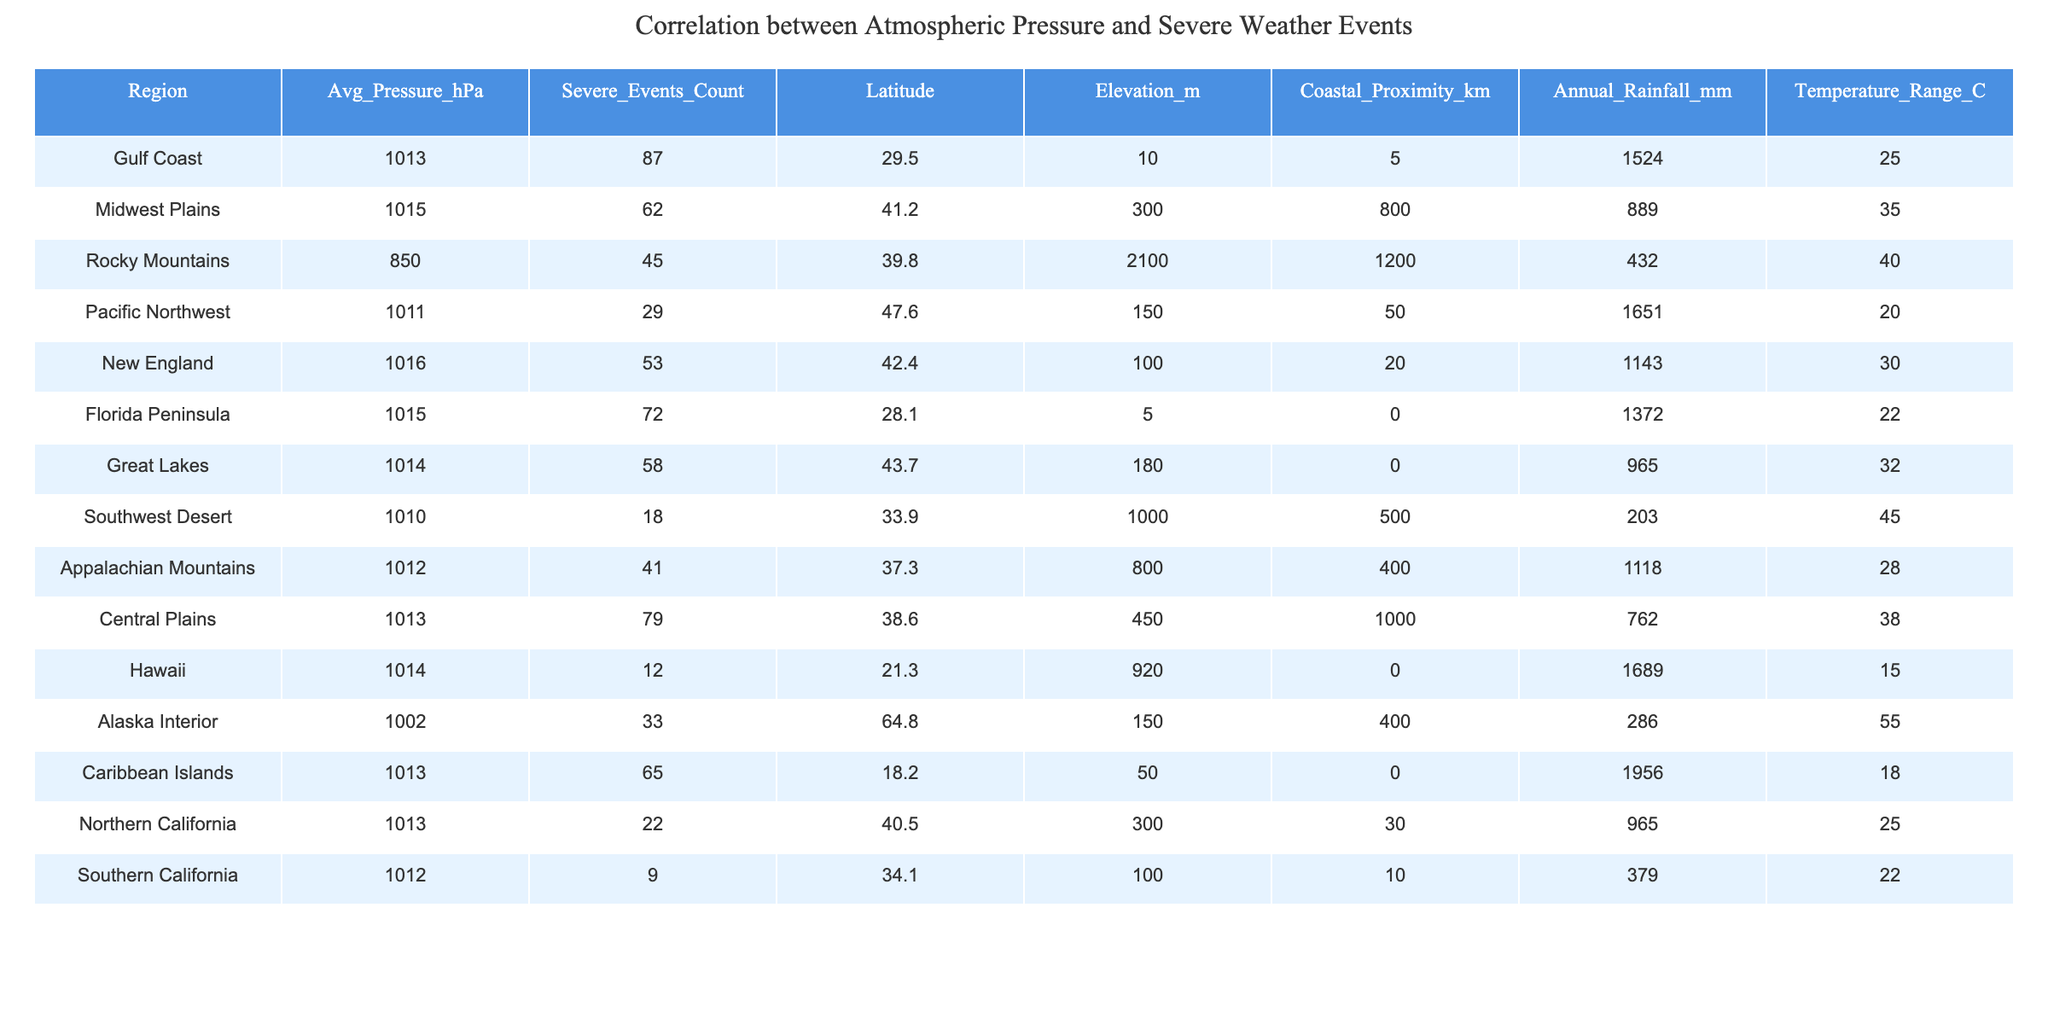What is the average atmospheric pressure for the Gulf Coast? The average atmospheric pressure for the Gulf Coast is listed directly in the table as 1013 hPa.
Answer: 1013 hPa Which region has the highest number of severe weather events? By comparing the "Severe Events Count" column, the Gulf Coast with 87 events has the highest number of severe weather events among the listed regions.
Answer: Gulf Coast What is the average annual rainfall for the Rocky Mountains? The average annual rainfall for the Rocky Mountains can be retrieved from the table, which indicates it is 432 mm.
Answer: 432 mm Is the Florida Peninsula closer to the coast compared to the Pacific Northwest? The "Coastal Proximity" for Florida Peninsula is 0 km, while for Pacific Northwest it is 50 km. Therefore, Florida Peninsula is closer to the coast.
Answer: Yes How many severe weather events are reported in the Central Plains? According to the table, the Central Plains have a total of 79 severe weather events.
Answer: 79 What is the difference in average pressure between the Midwest Plains and the Rocky Mountains? The average pressure for the Midwest Plains is 1015 hPa and for the Rocky Mountains it is 850 hPa. The difference is 1015 - 850 = 165 hPa.
Answer: 165 hPa What is the average temperature range for the regions listed? The average temperature range can be calculated by summing the individual ranges (25 + 35 + 40 + 20 + 30 + 22 + 32 + 45 + 28 + 38 + 15 + 55 + 18 + 25 + 22 =  535) and dividing by the number of regions (15), which gives an average of 535/15 ≈ 35.67.
Answer: 35.67 Which region has the highest elevation, and what is that elevation? By looking at the "Elevation" column, the Rocky Mountains have the highest elevation at 2100 meters.
Answer: Rocky Mountains, 2100 m Are there any regions where the average pressure is below 1000 hPa? The lowest average pressure recorded in the table is 1002 hPa for the Alaska Interior, which is not below 1000 hPa, so the answer is no.
Answer: No Which two regions have the closest average atmospheric pressures? The average pressures for the Gulf Coast (1013 hPa) and Central Plains (1013 hPa) are the same; thus, they have the closest values.
Answer: Gulf Coast and Central Plains How many severe weather events occurred in the Southwest Desert region? The table indicates that there are 18 severe weather events recorded in the Southwest Desert region.
Answer: 18 